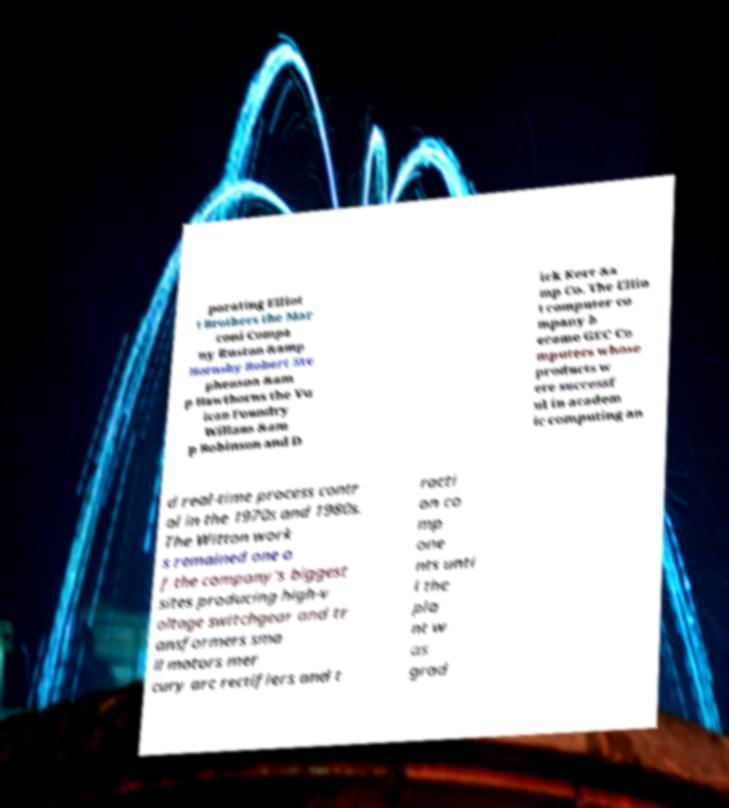I need the written content from this picture converted into text. Can you do that? porating Elliot t Brothers the Mar coni Compa ny Ruston &amp Hornsby Robert Ste phenson &am p Hawthorns the Vu lcan Foundry Willans &am p Robinson and D ick Kerr &a mp Co. The Ellio t computer co mpany b ecame GEC Co mputers whose products w ere successf ul in academ ic computing an d real-time process contr ol in the 1970s and 1980s. The Witton work s remained one o f the company's biggest sites producing high-v oltage switchgear and tr ansformers sma ll motors mer cury arc rectifiers and t racti on co mp one nts unti l the pla nt w as grad 